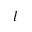<formula> <loc_0><loc_0><loc_500><loc_500>l</formula> 